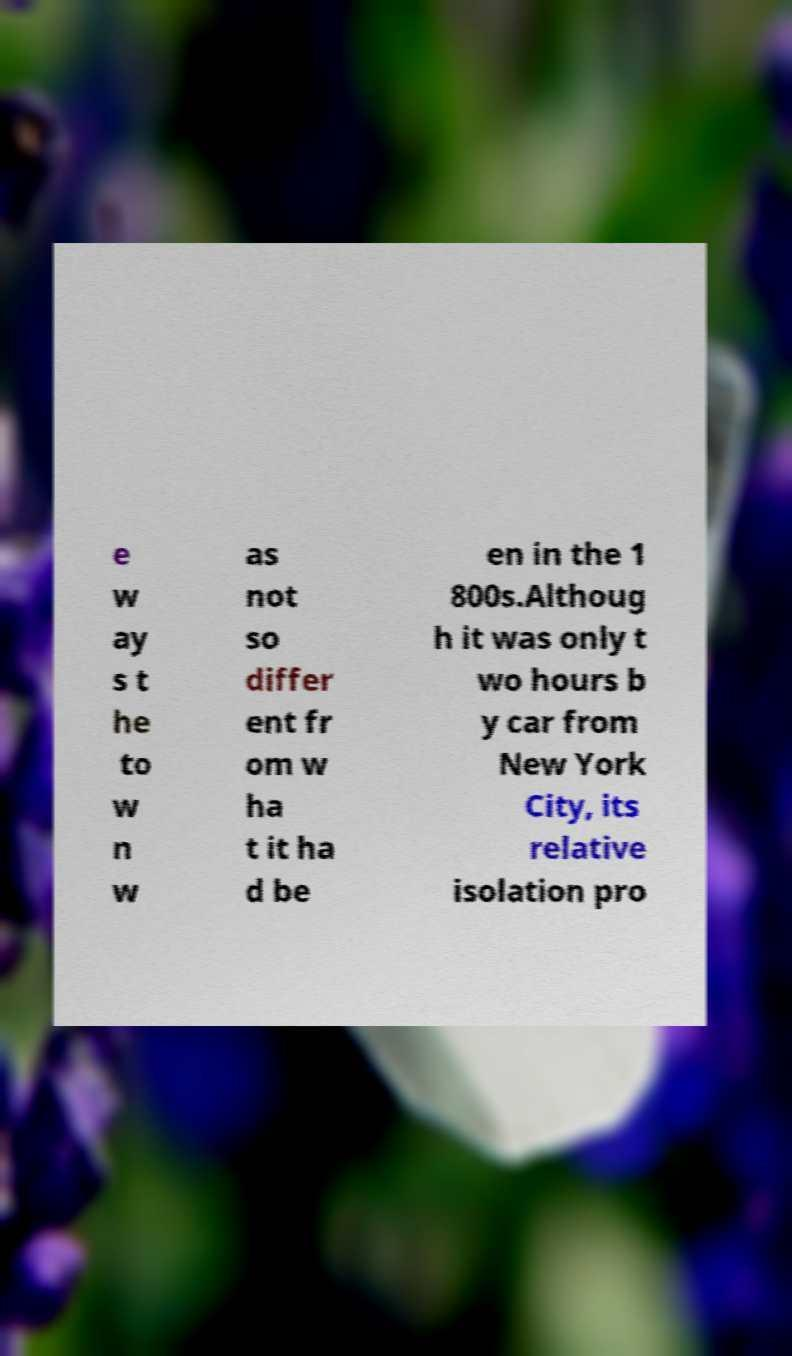Can you read and provide the text displayed in the image?This photo seems to have some interesting text. Can you extract and type it out for me? e w ay s t he to w n w as not so differ ent fr om w ha t it ha d be en in the 1 800s.Althoug h it was only t wo hours b y car from New York City, its relative isolation pro 